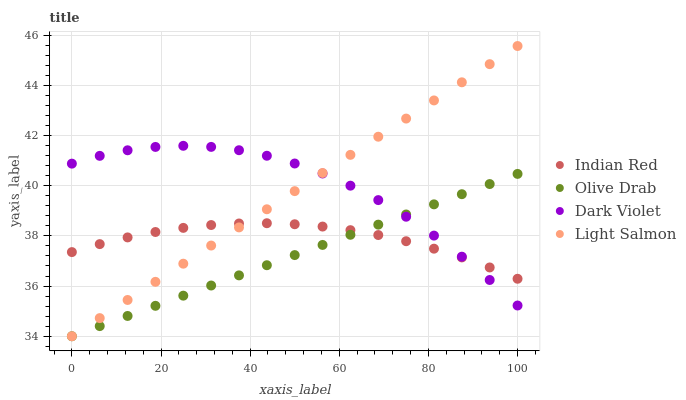Does Olive Drab have the minimum area under the curve?
Answer yes or no. Yes. Does Dark Violet have the maximum area under the curve?
Answer yes or no. Yes. Does Indian Red have the minimum area under the curve?
Answer yes or no. No. Does Indian Red have the maximum area under the curve?
Answer yes or no. No. Is Light Salmon the smoothest?
Answer yes or no. Yes. Is Dark Violet the roughest?
Answer yes or no. Yes. Is Olive Drab the smoothest?
Answer yes or no. No. Is Olive Drab the roughest?
Answer yes or no. No. Does Olive Drab have the lowest value?
Answer yes or no. Yes. Does Indian Red have the lowest value?
Answer yes or no. No. Does Light Salmon have the highest value?
Answer yes or no. Yes. Does Olive Drab have the highest value?
Answer yes or no. No. Does Dark Violet intersect Olive Drab?
Answer yes or no. Yes. Is Dark Violet less than Olive Drab?
Answer yes or no. No. Is Dark Violet greater than Olive Drab?
Answer yes or no. No. 